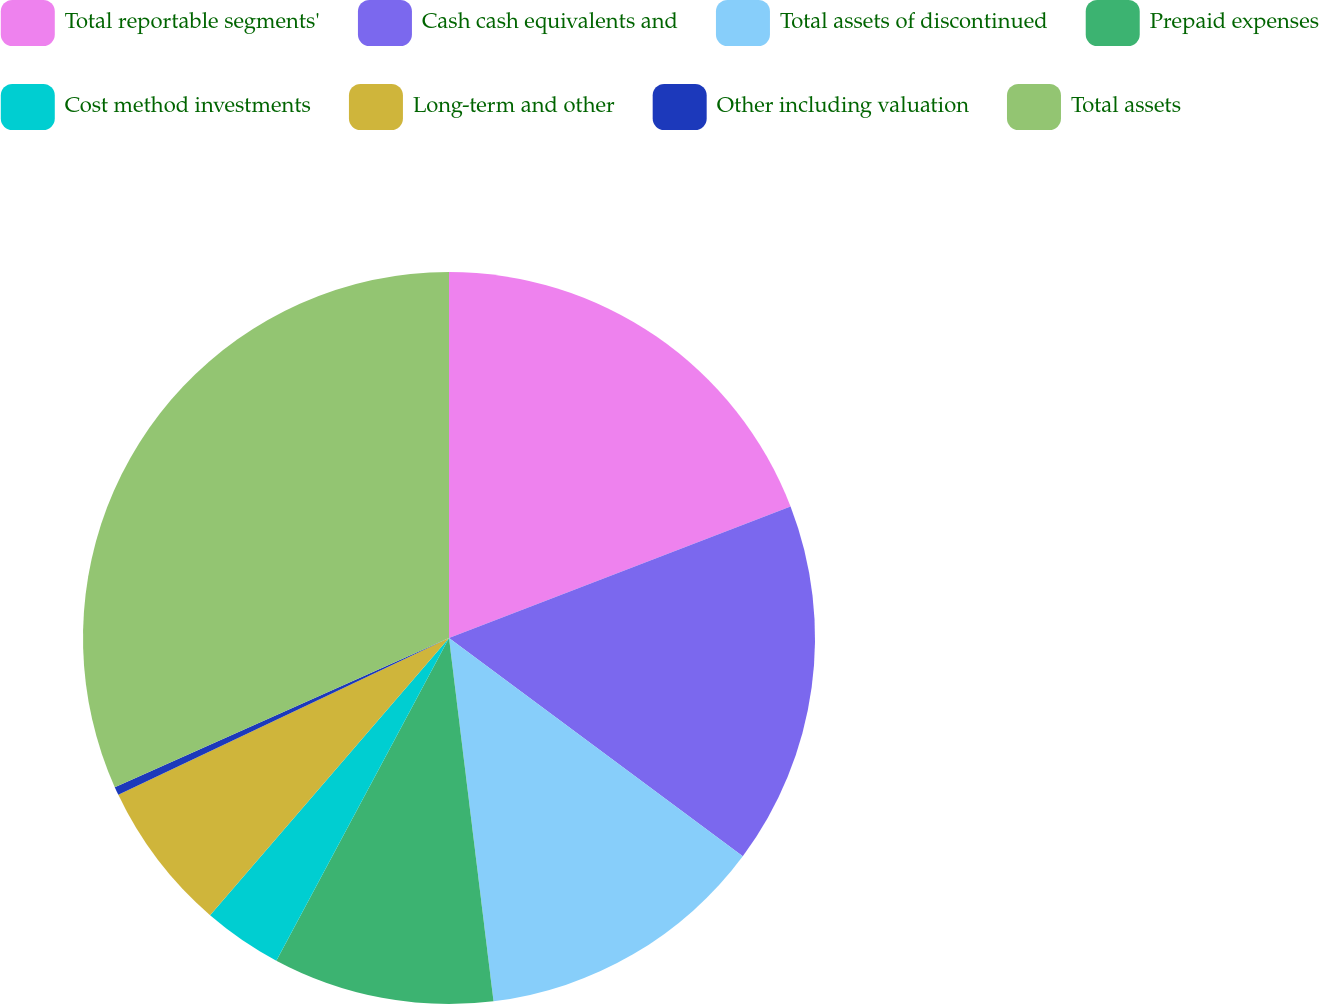Convert chart to OTSL. <chart><loc_0><loc_0><loc_500><loc_500><pie_chart><fcel>Total reportable segments'<fcel>Cash cash equivalents and<fcel>Total assets of discontinued<fcel>Prepaid expenses<fcel>Cost method investments<fcel>Long-term and other<fcel>Other including valuation<fcel>Total assets<nl><fcel>19.15%<fcel>16.02%<fcel>12.89%<fcel>9.76%<fcel>3.5%<fcel>6.63%<fcel>0.37%<fcel>31.68%<nl></chart> 